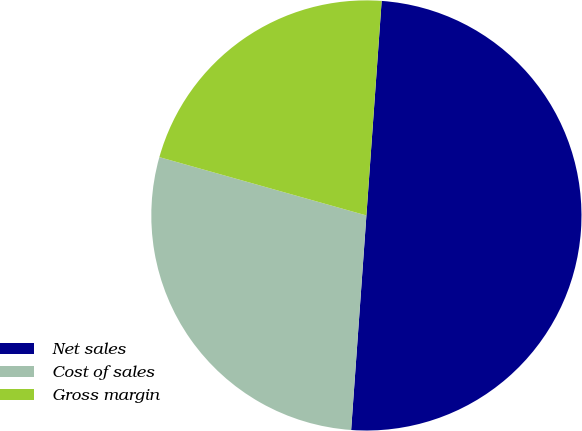Convert chart. <chart><loc_0><loc_0><loc_500><loc_500><pie_chart><fcel>Net sales<fcel>Cost of sales<fcel>Gross margin<nl><fcel>50.0%<fcel>28.24%<fcel>21.76%<nl></chart> 